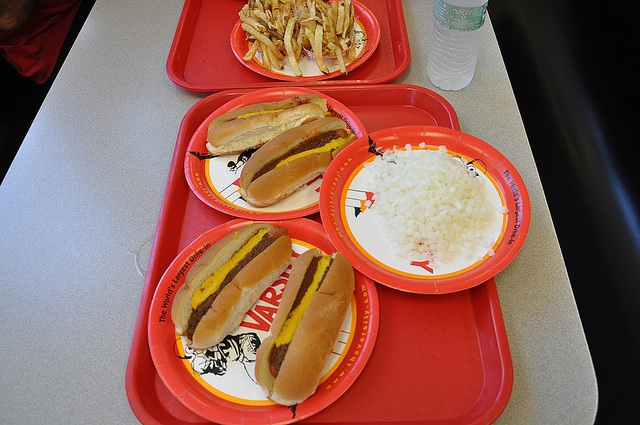Describe the objects in this image and their specific colors. I can see dining table in black, darkgray, and gray tones, hot dog in black, red, tan, and maroon tones, hot dog in black, olive, tan, and maroon tones, hot dog in black, olive, maroon, and tan tones, and hot dog in black, tan, and olive tones in this image. 